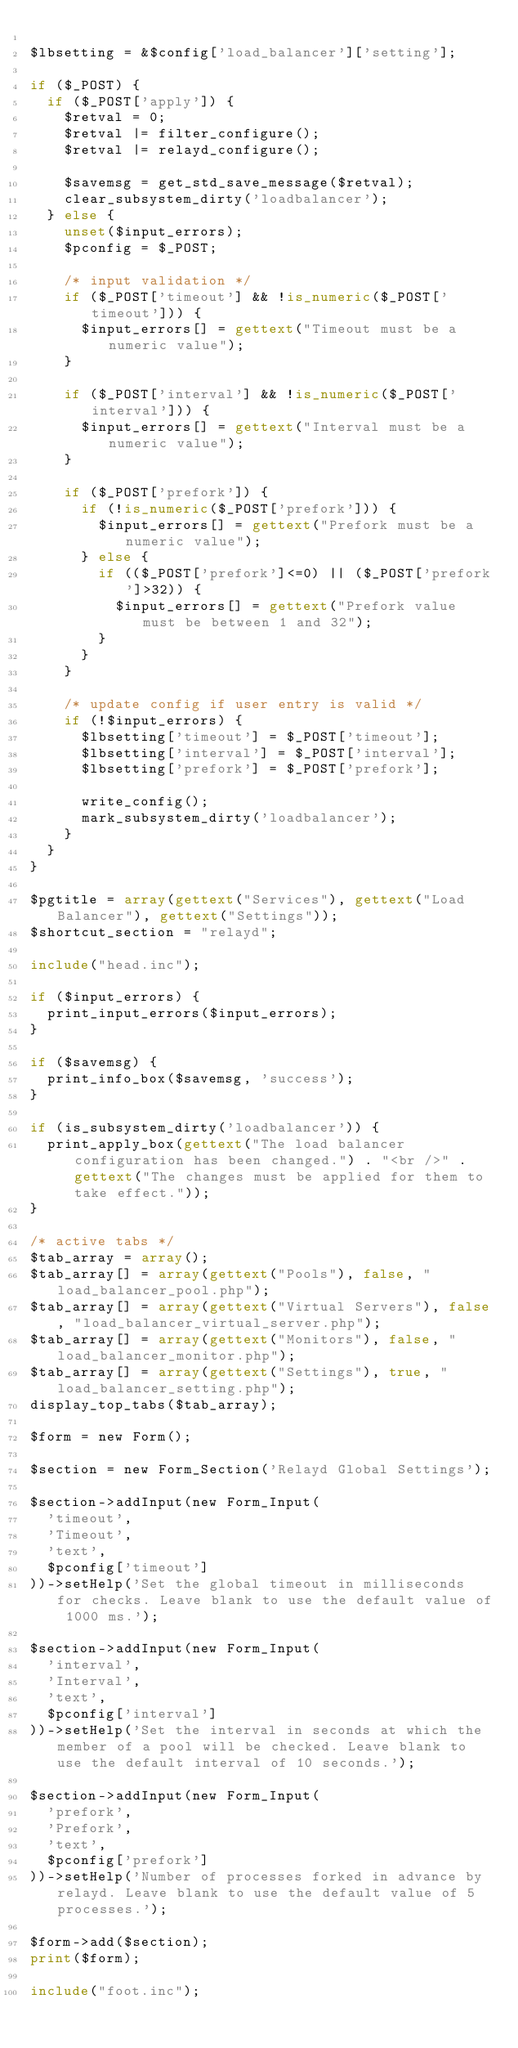<code> <loc_0><loc_0><loc_500><loc_500><_PHP_>
$lbsetting = &$config['load_balancer']['setting'];

if ($_POST) {
	if ($_POST['apply']) {
		$retval = 0;
		$retval |= filter_configure();
		$retval |= relayd_configure();

		$savemsg = get_std_save_message($retval);
		clear_subsystem_dirty('loadbalancer');
	} else {
		unset($input_errors);
		$pconfig = $_POST;

		/* input validation */
		if ($_POST['timeout'] && !is_numeric($_POST['timeout'])) {
			$input_errors[] = gettext("Timeout must be a numeric value");
		}

		if ($_POST['interval'] && !is_numeric($_POST['interval'])) {
			$input_errors[] = gettext("Interval must be a numeric value");
		}

		if ($_POST['prefork']) {
			if (!is_numeric($_POST['prefork'])) {
				$input_errors[] = gettext("Prefork must be a numeric value");
			} else {
				if (($_POST['prefork']<=0) || ($_POST['prefork']>32)) {
					$input_errors[] = gettext("Prefork value must be between 1 and 32");
				}
			}
		}

		/* update config if user entry is valid */
		if (!$input_errors) {
			$lbsetting['timeout'] = $_POST['timeout'];
			$lbsetting['interval'] = $_POST['interval'];
			$lbsetting['prefork'] = $_POST['prefork'];

			write_config();
			mark_subsystem_dirty('loadbalancer');
		}
	}
}

$pgtitle = array(gettext("Services"), gettext("Load Balancer"), gettext("Settings"));
$shortcut_section = "relayd";

include("head.inc");

if ($input_errors) {
	print_input_errors($input_errors);
}

if ($savemsg) {
	print_info_box($savemsg, 'success');
}

if (is_subsystem_dirty('loadbalancer')) {
	print_apply_box(gettext("The load balancer configuration has been changed.") . "<br />" . gettext("The changes must be applied for them to take effect."));
}

/* active tabs */
$tab_array = array();
$tab_array[] = array(gettext("Pools"), false, "load_balancer_pool.php");
$tab_array[] = array(gettext("Virtual Servers"), false, "load_balancer_virtual_server.php");
$tab_array[] = array(gettext("Monitors"), false, "load_balancer_monitor.php");
$tab_array[] = array(gettext("Settings"), true, "load_balancer_setting.php");
display_top_tabs($tab_array);

$form = new Form();

$section = new Form_Section('Relayd Global Settings');

$section->addInput(new Form_Input(
	'timeout',
	'Timeout',
	'text',
	$pconfig['timeout']
))->setHelp('Set the global timeout in milliseconds for checks. Leave blank to use the default value of 1000 ms.');

$section->addInput(new Form_Input(
	'interval',
	'Interval',
	'text',
	$pconfig['interval']
))->setHelp('Set the interval in seconds at which the member of a pool will be checked. Leave blank to use the default interval of 10 seconds.');

$section->addInput(new Form_Input(
	'prefork',
	'Prefork',
	'text',
	$pconfig['prefork']
))->setHelp('Number of processes forked in advance by relayd. Leave blank to use the default value of 5 processes.');

$form->add($section);
print($form);

include("foot.inc");
</code> 